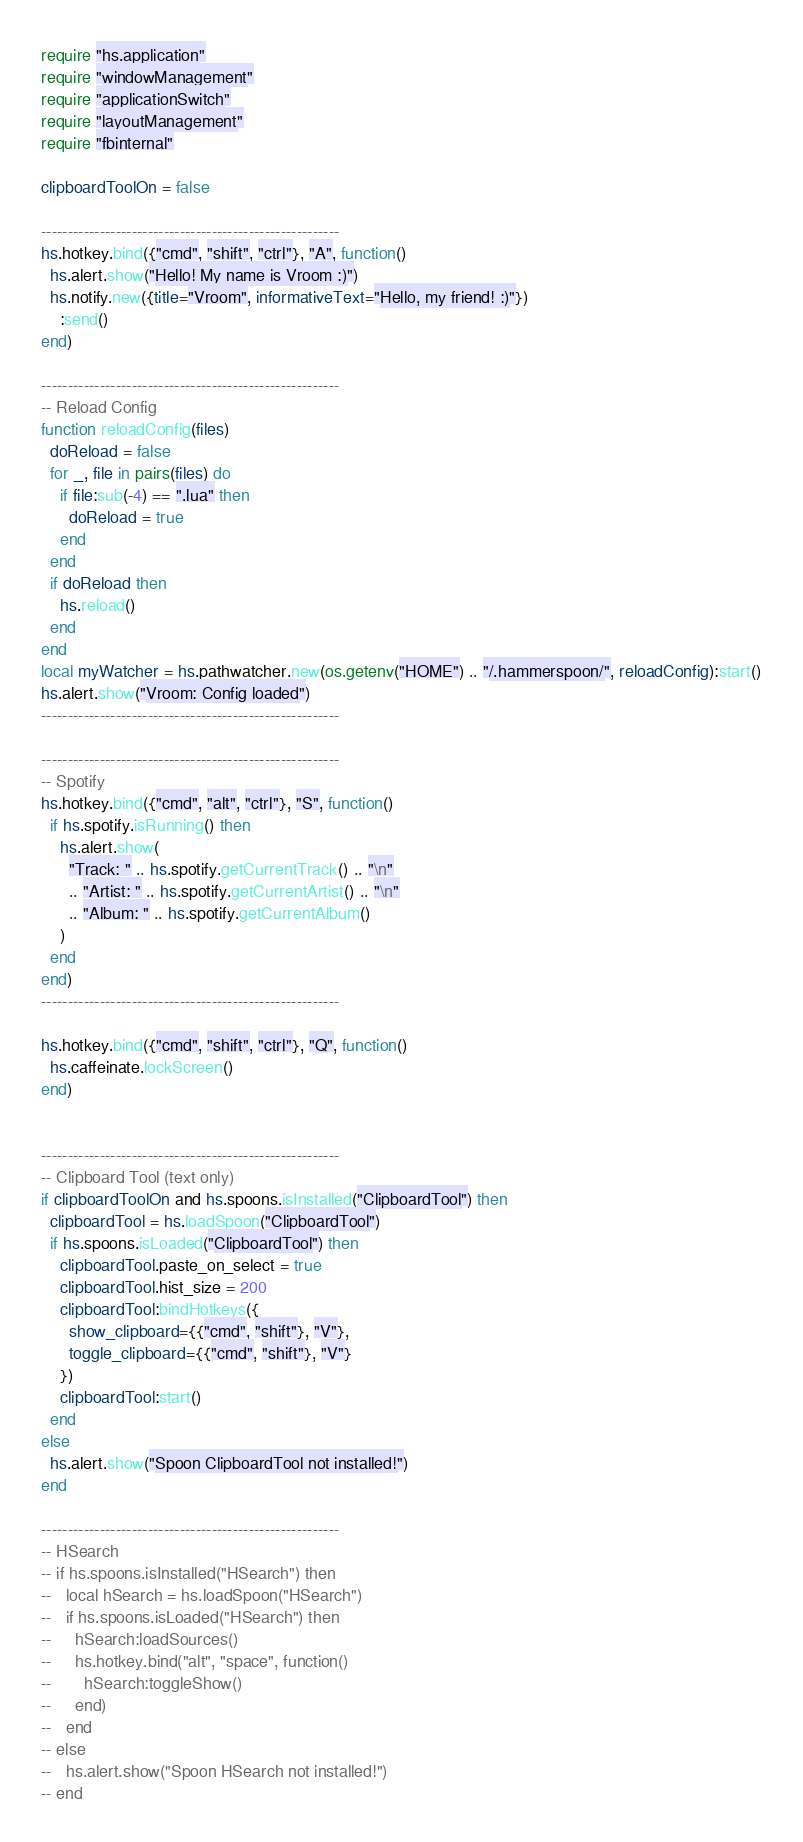<code> <loc_0><loc_0><loc_500><loc_500><_Lua_>
require "hs.application"
require "windowManagement"
require "applicationSwitch"
require "layoutManagement"
require "fbinternal"

clipboardToolOn = false

--------------------------------------------------------
hs.hotkey.bind({"cmd", "shift", "ctrl"}, "A", function()
  hs.alert.show("Hello! My name is Vroom :)")
  hs.notify.new({title="Vroom", informativeText="Hello, my friend! :)"})
    :send()
end)

--------------------------------------------------------
-- Reload Config
function reloadConfig(files)
  doReload = false
  for _, file in pairs(files) do
    if file:sub(-4) == ".lua" then
      doReload = true
    end
  end
  if doReload then
    hs.reload()
  end
end
local myWatcher = hs.pathwatcher.new(os.getenv("HOME") .. "/.hammerspoon/", reloadConfig):start()
hs.alert.show("Vroom: Config loaded")
--------------------------------------------------------

--------------------------------------------------------
-- Spotify
hs.hotkey.bind({"cmd", "alt", "ctrl"}, "S", function()
  if hs.spotify.isRunning() then
    hs.alert.show(
      "Track: " .. hs.spotify.getCurrentTrack() .. "\n"
      .. "Artist: " .. hs.spotify.getCurrentArtist() .. "\n"
      .. "Album: " .. hs.spotify.getCurrentAlbum()
    )
  end
end)
--------------------------------------------------------

hs.hotkey.bind({"cmd", "shift", "ctrl"}, "Q", function()
  hs.caffeinate.lockScreen()
end)


--------------------------------------------------------
-- Clipboard Tool (text only)
if clipboardToolOn and hs.spoons.isInstalled("ClipboardTool") then
  clipboardTool = hs.loadSpoon("ClipboardTool")
  if hs.spoons.isLoaded("ClipboardTool") then 
    clipboardTool.paste_on_select = true
    clipboardTool.hist_size = 200
    clipboardTool:bindHotkeys({
      show_clipboard={{"cmd", "shift"}, "V"},
      toggle_clipboard={{"cmd", "shift"}, "V"}
    })
    clipboardTool:start()
  end
else
  hs.alert.show("Spoon ClipboardTool not installed!")
end

--------------------------------------------------------
-- HSearch 
-- if hs.spoons.isInstalled("HSearch") then
--   local hSearch = hs.loadSpoon("HSearch")
--   if hs.spoons.isLoaded("HSearch") then 
--     hSearch:loadSources()
--     hs.hotkey.bind("alt", "space", function()
--       hSearch:toggleShow()
--     end)
--   end
-- else
--   hs.alert.show("Spoon HSearch not installed!")
-- end
</code> 